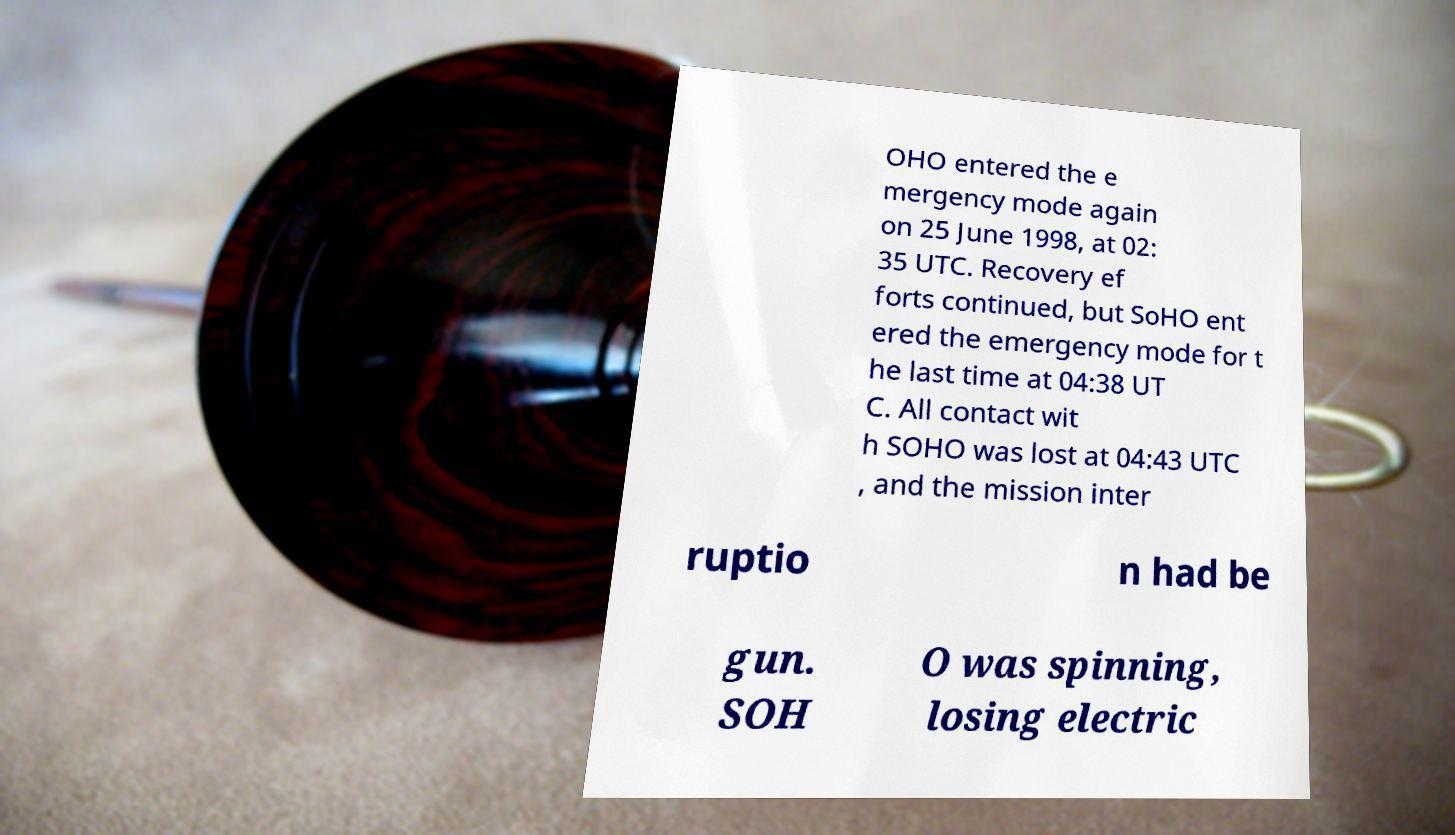Can you accurately transcribe the text from the provided image for me? OHO entered the e mergency mode again on 25 June 1998, at 02: 35 UTC. Recovery ef forts continued, but SoHO ent ered the emergency mode for t he last time at 04:38 UT C. All contact wit h SOHO was lost at 04:43 UTC , and the mission inter ruptio n had be gun. SOH O was spinning, losing electric 